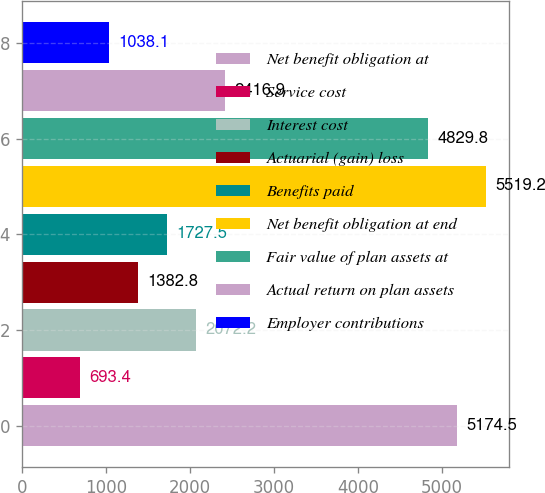<chart> <loc_0><loc_0><loc_500><loc_500><bar_chart><fcel>Net benefit obligation at<fcel>Service cost<fcel>Interest cost<fcel>Actuarial (gain) loss<fcel>Benefits paid<fcel>Net benefit obligation at end<fcel>Fair value of plan assets at<fcel>Actual return on plan assets<fcel>Employer contributions<nl><fcel>5174.5<fcel>693.4<fcel>2072.2<fcel>1382.8<fcel>1727.5<fcel>5519.2<fcel>4829.8<fcel>2416.9<fcel>1038.1<nl></chart> 